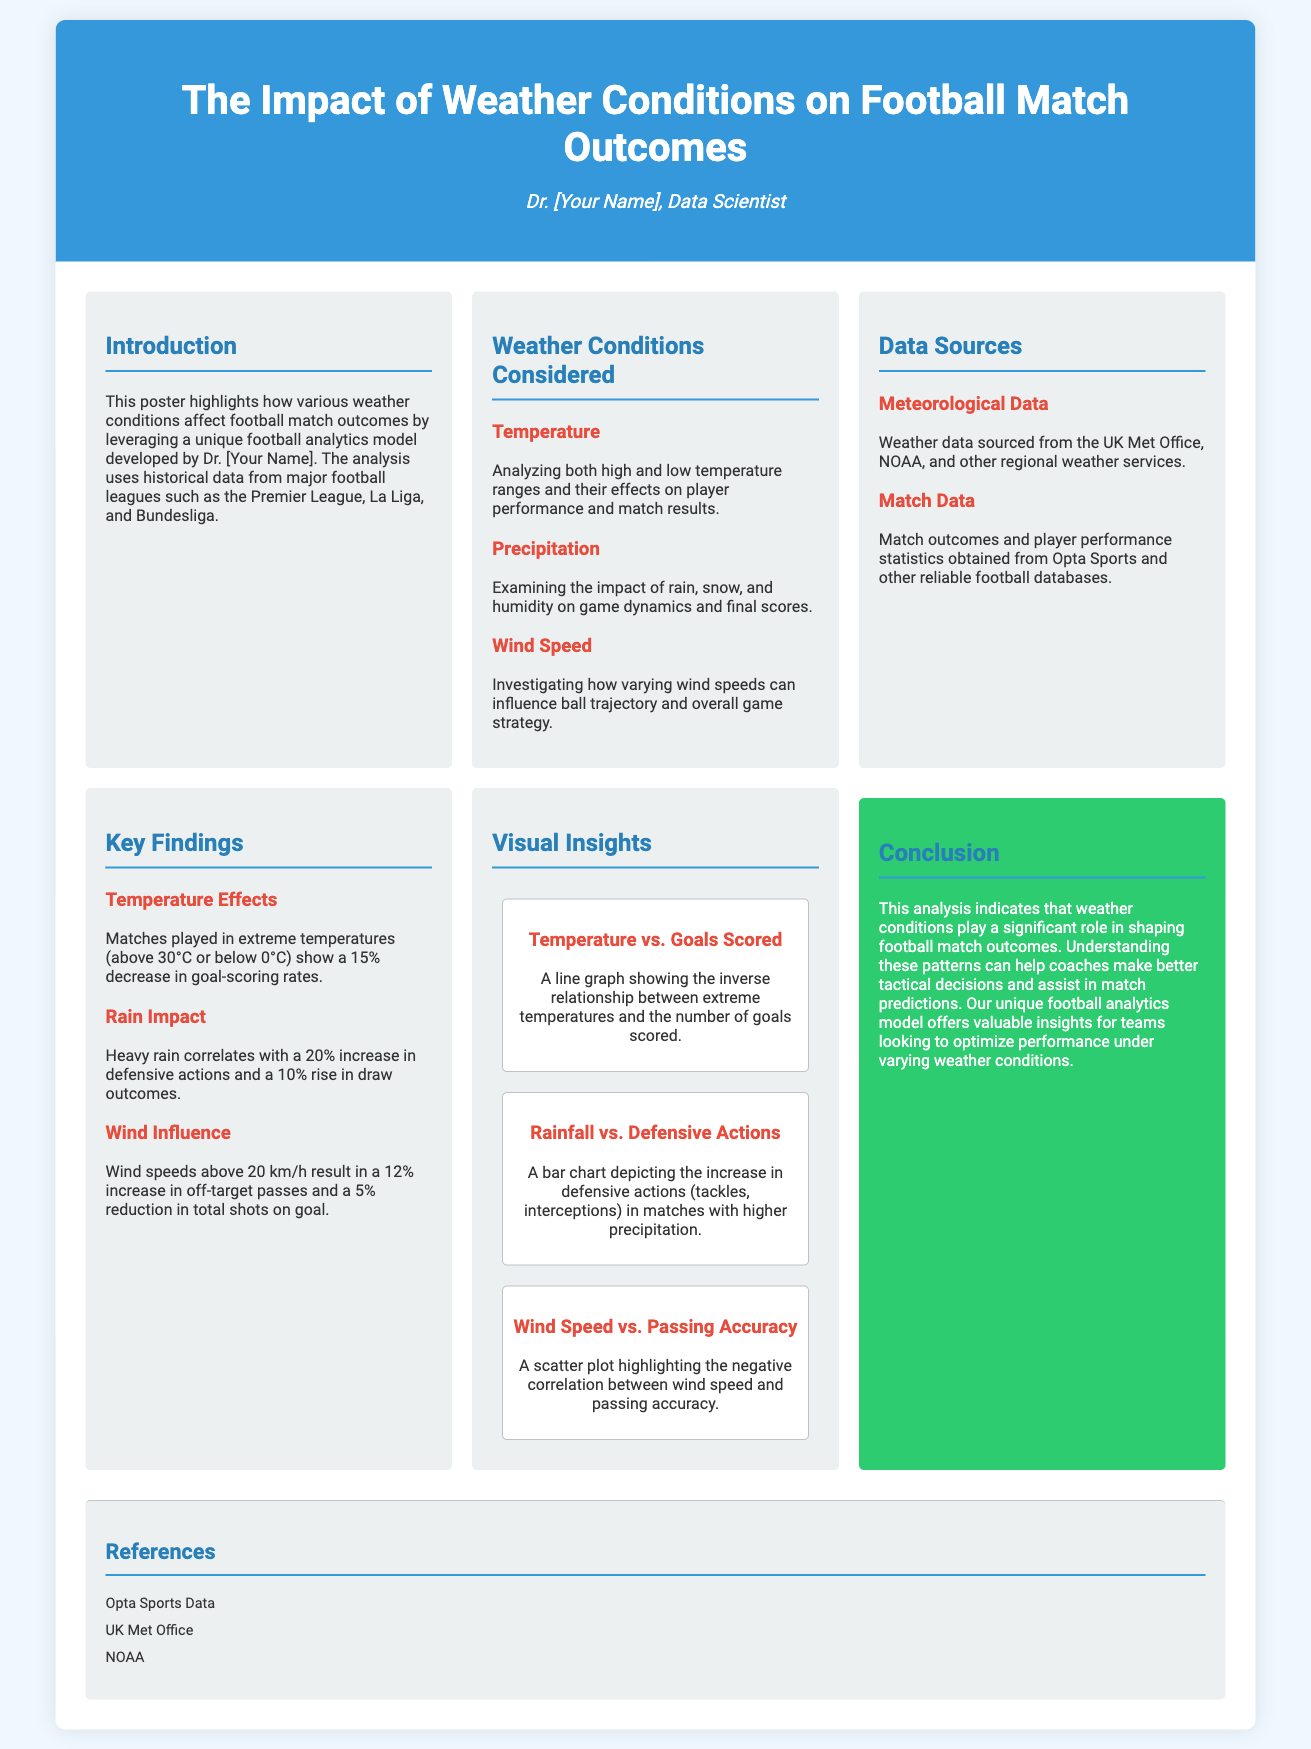What is the title of the poster? The title of the poster is the main heading displayed prominently at the top of the document.
Answer: The Impact of Weather Conditions on Football Match Outcomes Who is the author of the poster? The author is mentioned in the introduction section of the document, indicating their role and expertise.
Answer: Dr. [Your Name] What weather condition correlates with a 20% increase in defensive actions? The key findings section provides specific correlations and percentages related to different weather conditions.
Answer: Rain What percentage decrease in goal-scoring rates is observed in extreme temperatures? This statistic is mentioned under the temperature effects in the key findings section of the document.
Answer: 15% Which data source is related to meteorological information? The data sources section highlights the origins of the data used in the analysis.
Answer: UK Met Office What is the effect of wind speeds above 20 km/h on total shots on goal? The document states specific effects of wind speed on game performance metrics in the key findings section.
Answer: 5% reduction What type of chart depicts the relationship between rainfall and defensive actions? The visual insights section describes different visualizations used to present the data findings.
Answer: Bar chart What does the conclusion suggest about understanding weather patterns? The conclusion provides the implications of the findings and how they relate to tactical decisions in football.
Answer: Assist in match predictions 